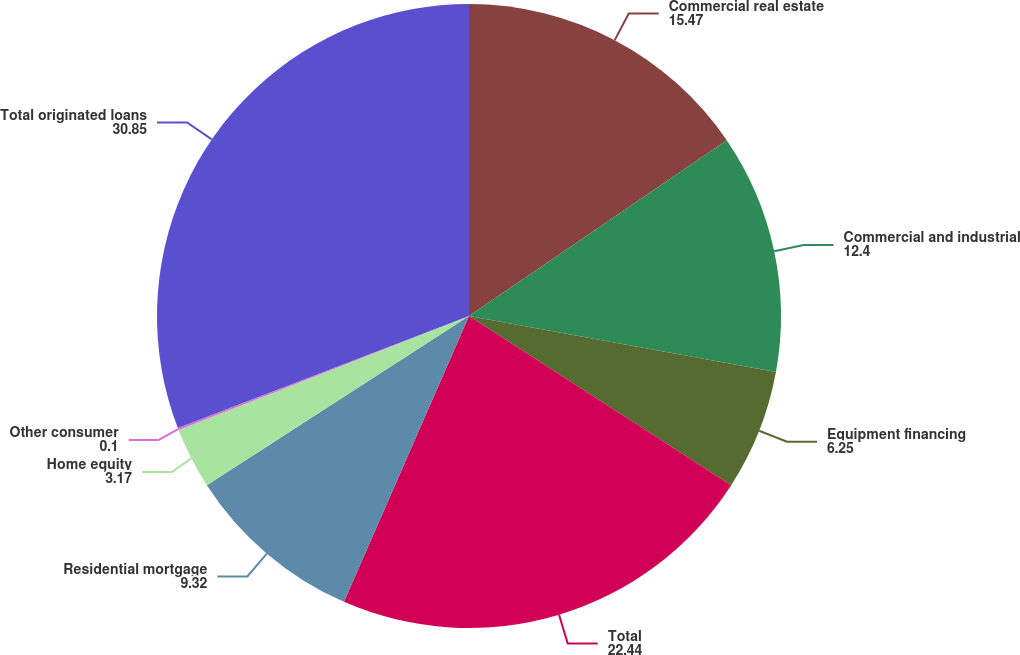<chart> <loc_0><loc_0><loc_500><loc_500><pie_chart><fcel>Commercial real estate<fcel>Commercial and industrial<fcel>Equipment financing<fcel>Total<fcel>Residential mortgage<fcel>Home equity<fcel>Other consumer<fcel>Total originated loans<nl><fcel>15.47%<fcel>12.4%<fcel>6.25%<fcel>22.44%<fcel>9.32%<fcel>3.17%<fcel>0.1%<fcel>30.85%<nl></chart> 